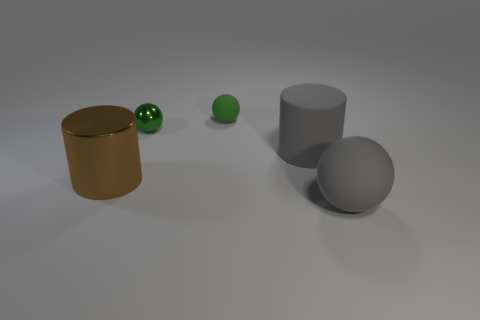Add 5 cylinders. How many objects exist? 10 Subtract all balls. How many objects are left? 2 Subtract all large gray cubes. Subtract all small green objects. How many objects are left? 3 Add 2 large gray rubber cylinders. How many large gray rubber cylinders are left? 3 Add 4 big brown cylinders. How many big brown cylinders exist? 5 Subtract 0 yellow cylinders. How many objects are left? 5 